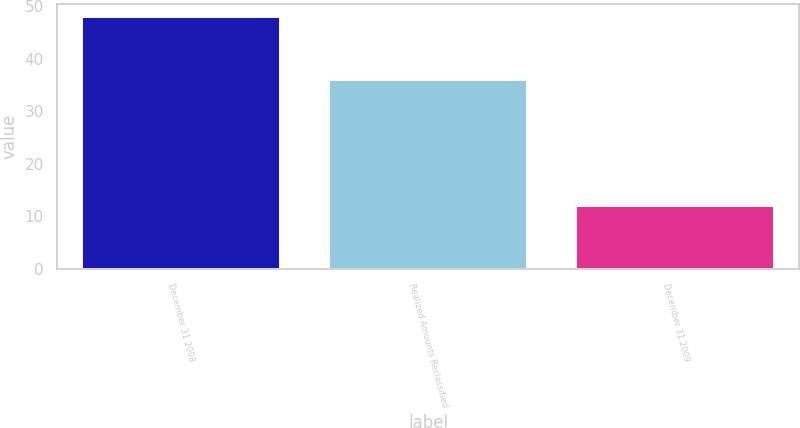Convert chart. <chart><loc_0><loc_0><loc_500><loc_500><bar_chart><fcel>December 31 2008<fcel>Realized Amounts Reclassified<fcel>December 31 2009<nl><fcel>48<fcel>36<fcel>12<nl></chart> 